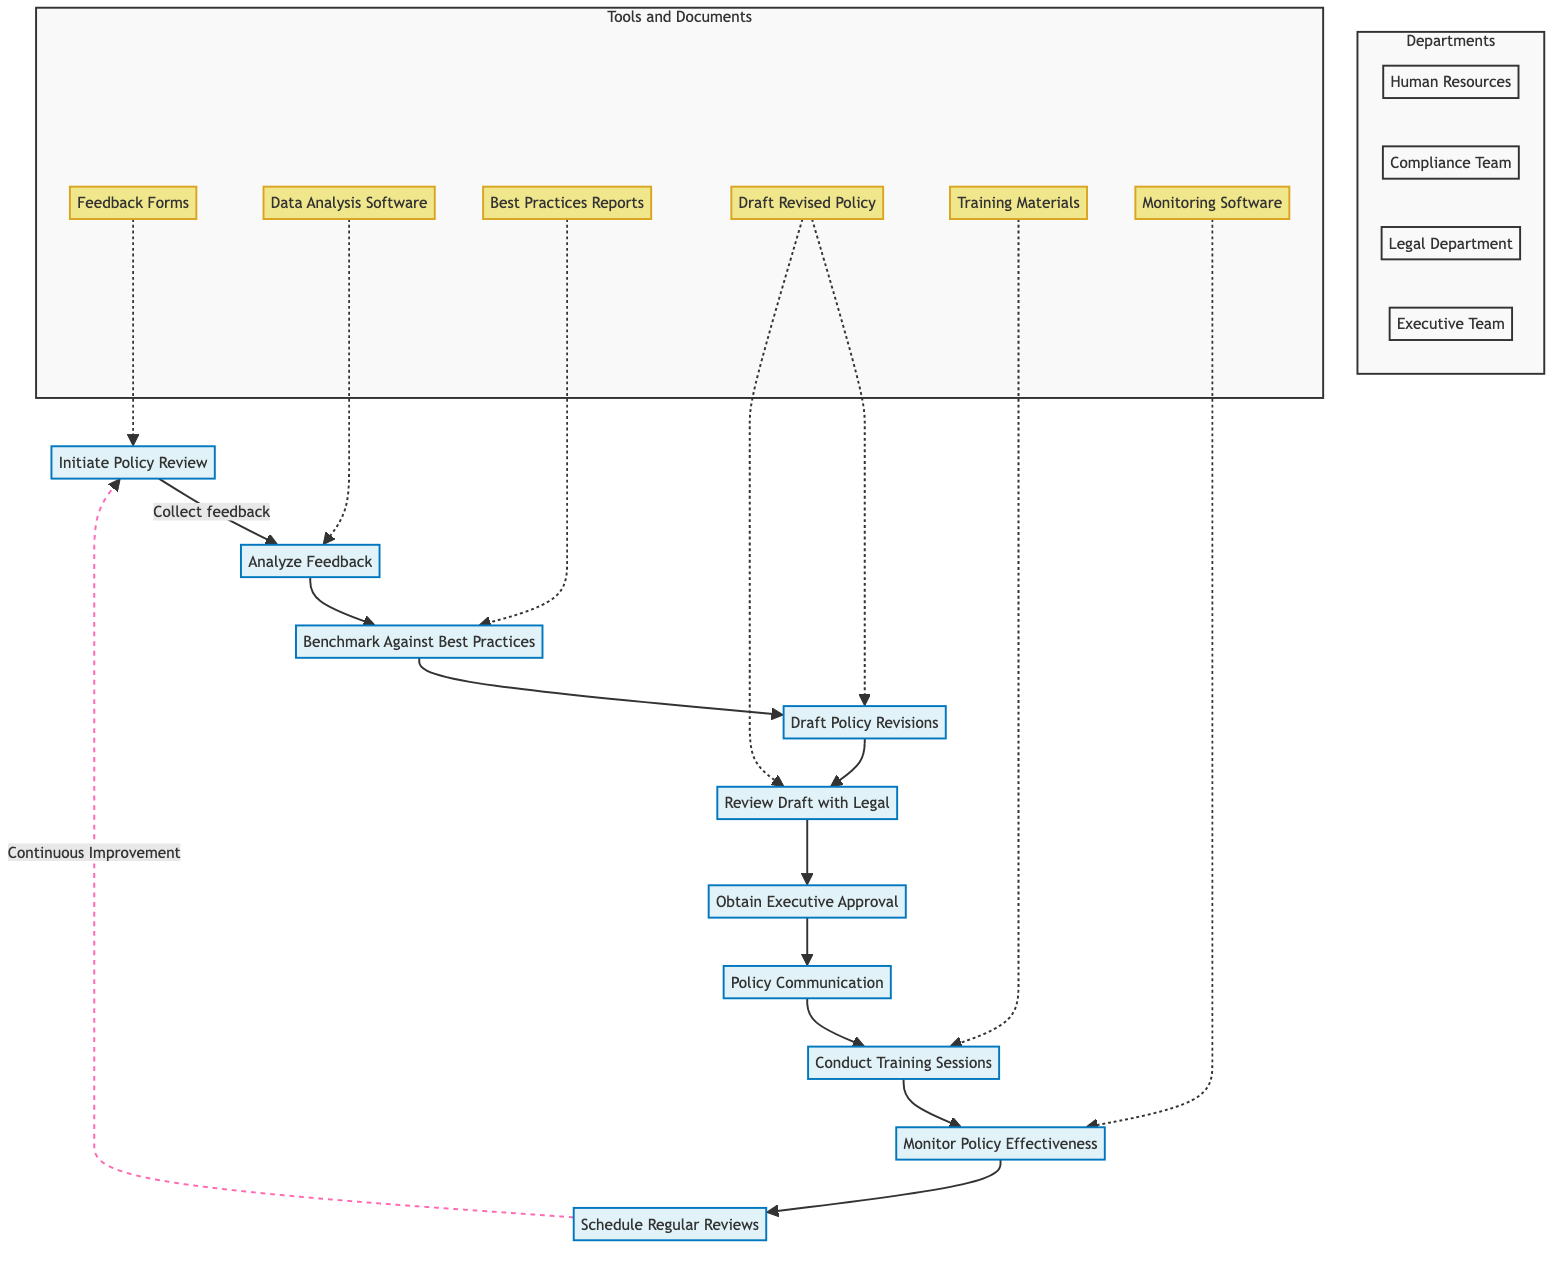What is the first step in the process? The first step listed in the flowchart is "Initiate Policy Review." This is indicated at the top of the diagram, showing the starting point of the process.
Answer: Initiate Policy Review Which department is responsible for analyzing feedback? The flowchart shows that the "Compliance Team" is responsible for the "Analyze Feedback" step. This is seen as the second node in the diagram connected to the first step.
Answer: Compliance Team How many departments are involved in the process? By counting the unique departments listed in the flowchart, there are four: Human Resources, Compliance Team, Legal Department, and Executive Team. Each department appears distinctly in the subgraph section.
Answer: Four What action is taken after obtaining executive approval? The flowchart indicates that after "Obtain Executive Approval," the next action is "Policy Communication." This is shown as a direct connection between the two nodes in the flowchart.
Answer: Policy Communication How does feedback contribute to the policy improvement process? The feedback collected in the "Initiate Policy Review" step feeds into the "Analyze Feedback" step where it's analyzed. This action is critical as it provides the foundation for potential revisions in the policy.
Answer: Analyzed What document is required for the review of the draft by the Legal Department? The flowchart specifies that the "Legal Compliance Checklist" is required when reviewing the draft. This document is listed under the "Review Draft with Legal" step.
Answer: Legal Compliance Checklist Which step involves training sessions? The diagram shows that "Conduct Training Sessions" is the action that involves training. This follows the "Policy Communication" step and is clearly marked as a process in the flowchart.
Answer: Conduct Training Sessions What is the last action in the flowchart before reverting to the first step? The last action before connecting back to the first step is "Schedule Regular Reviews." This indicates an ongoing cycle of review and improvement in the policy mechanism.
Answer: Schedule Regular Reviews How many steps are there in total in the process? By counting each node connected sequentially, there are ten distinct steps outlined in the flowchart. This includes all actions from initiation to scheduling regular reviews.
Answer: Ten 